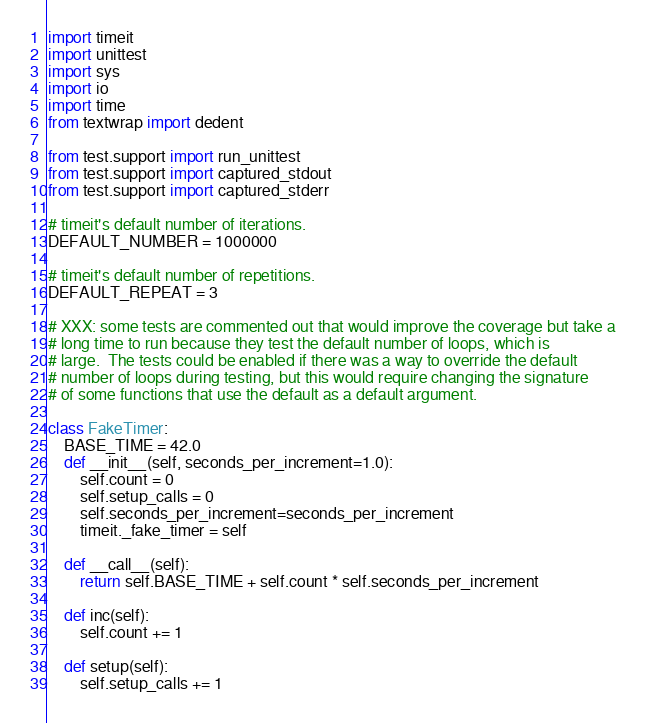Convert code to text. <code><loc_0><loc_0><loc_500><loc_500><_Python_>import timeit
import unittest
import sys
import io
import time
from textwrap import dedent

from test.support import run_unittest
from test.support import captured_stdout
from test.support import captured_stderr

# timeit's default number of iterations.
DEFAULT_NUMBER = 1000000

# timeit's default number of repetitions.
DEFAULT_REPEAT = 3

# XXX: some tests are commented out that would improve the coverage but take a
# long time to run because they test the default number of loops, which is
# large.  The tests could be enabled if there was a way to override the default
# number of loops during testing, but this would require changing the signature
# of some functions that use the default as a default argument.

class FakeTimer:
    BASE_TIME = 42.0
    def __init__(self, seconds_per_increment=1.0):
        self.count = 0
        self.setup_calls = 0
        self.seconds_per_increment=seconds_per_increment
        timeit._fake_timer = self

    def __call__(self):
        return self.BASE_TIME + self.count * self.seconds_per_increment

    def inc(self):
        self.count += 1

    def setup(self):
        self.setup_calls += 1
</code> 